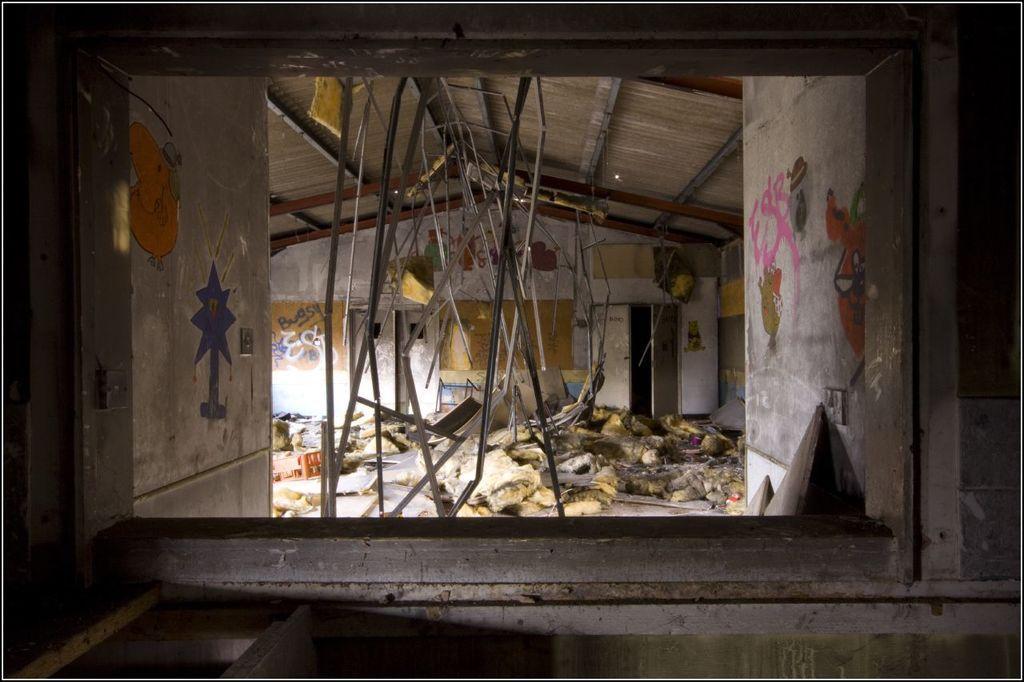How would you summarize this image in a sentence or two? In this image, we can see an inside view of a shed. There is a scrap in the middle of the image. 